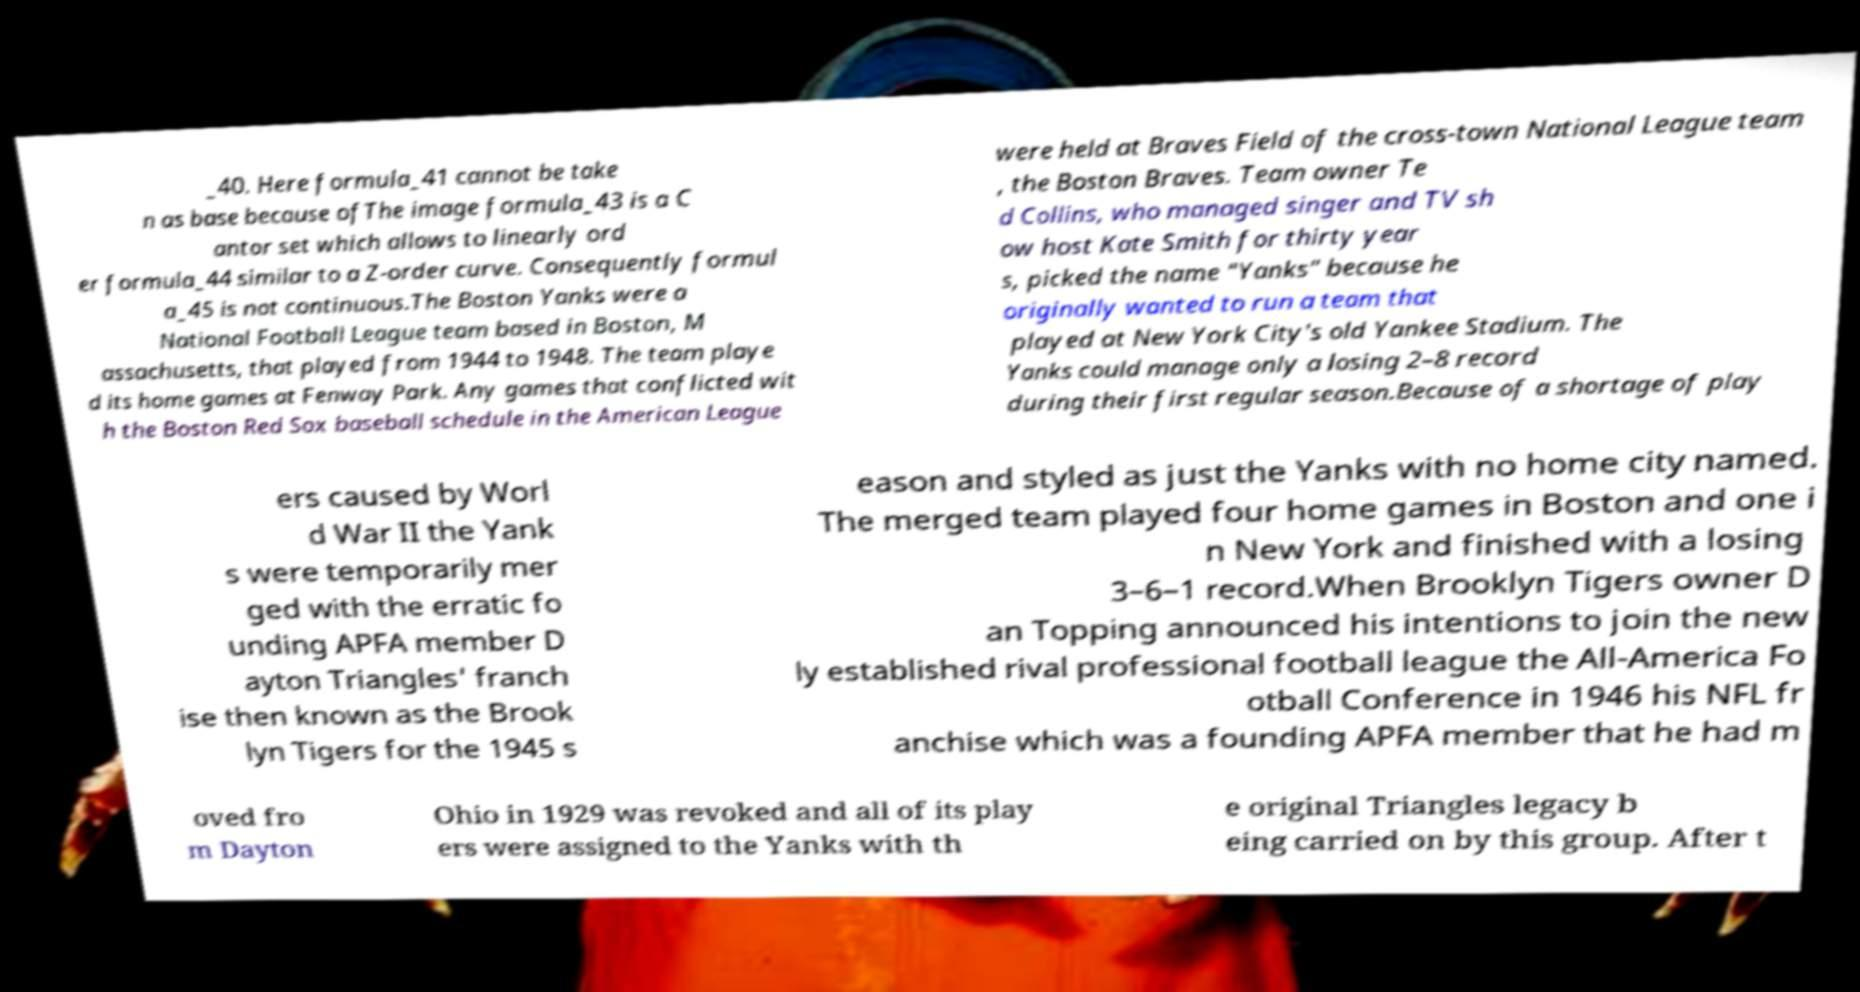For documentation purposes, I need the text within this image transcribed. Could you provide that? _40. Here formula_41 cannot be take n as base because ofThe image formula_43 is a C antor set which allows to linearly ord er formula_44 similar to a Z-order curve. Consequently formul a_45 is not continuous.The Boston Yanks were a National Football League team based in Boston, M assachusetts, that played from 1944 to 1948. The team playe d its home games at Fenway Park. Any games that conflicted wit h the Boston Red Sox baseball schedule in the American League were held at Braves Field of the cross-town National League team , the Boston Braves. Team owner Te d Collins, who managed singer and TV sh ow host Kate Smith for thirty year s, picked the name "Yanks" because he originally wanted to run a team that played at New York City's old Yankee Stadium. The Yanks could manage only a losing 2–8 record during their first regular season.Because of a shortage of play ers caused by Worl d War II the Yank s were temporarily mer ged with the erratic fo unding APFA member D ayton Triangles' franch ise then known as the Brook lyn Tigers for the 1945 s eason and styled as just the Yanks with no home city named. The merged team played four home games in Boston and one i n New York and finished with a losing 3–6–1 record.When Brooklyn Tigers owner D an Topping announced his intentions to join the new ly established rival professional football league the All-America Fo otball Conference in 1946 his NFL fr anchise which was a founding APFA member that he had m oved fro m Dayton Ohio in 1929 was revoked and all of its play ers were assigned to the Yanks with th e original Triangles legacy b eing carried on by this group. After t 